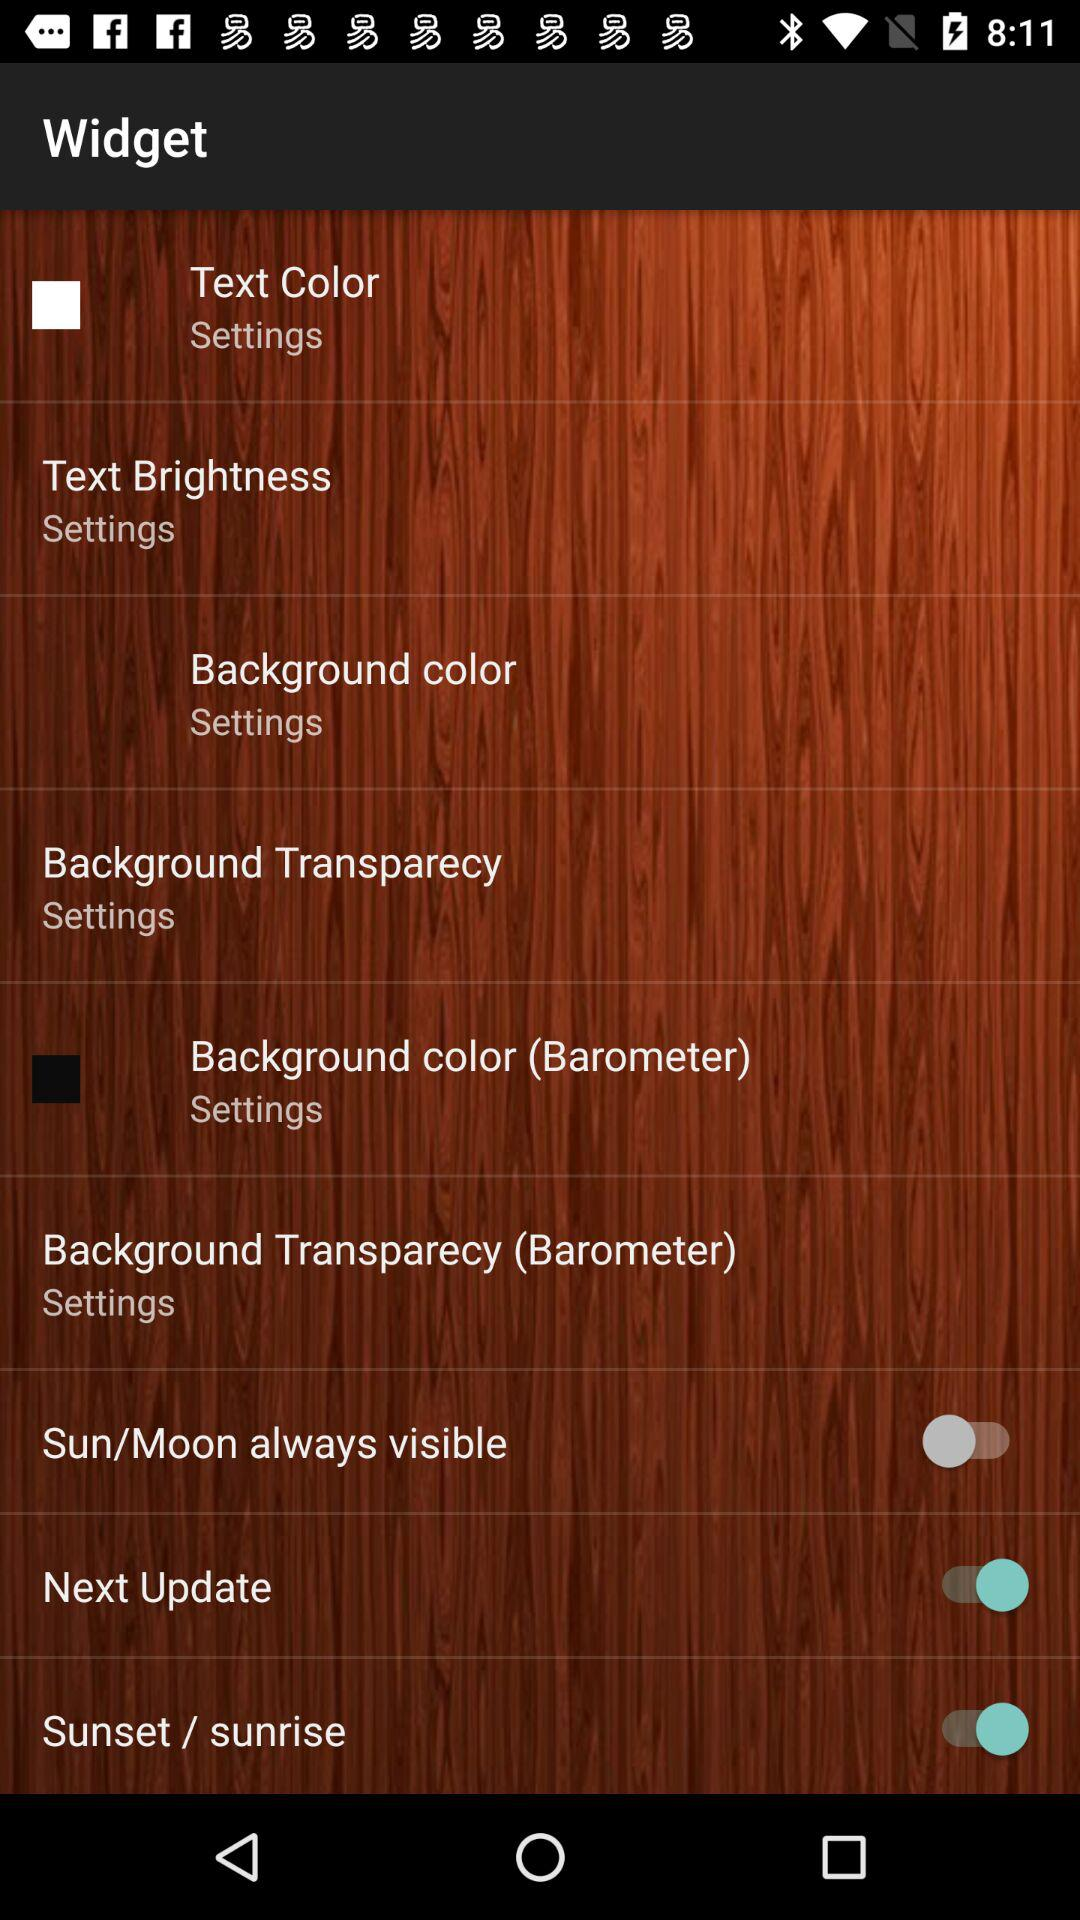How many text colors are available?
When the provided information is insufficient, respond with <no answer>. <no answer> 